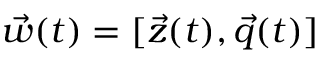<formula> <loc_0><loc_0><loc_500><loc_500>\vec { w } ( t ) = [ \vec { z } ( t ) , \vec { q } ( t ) ]</formula> 